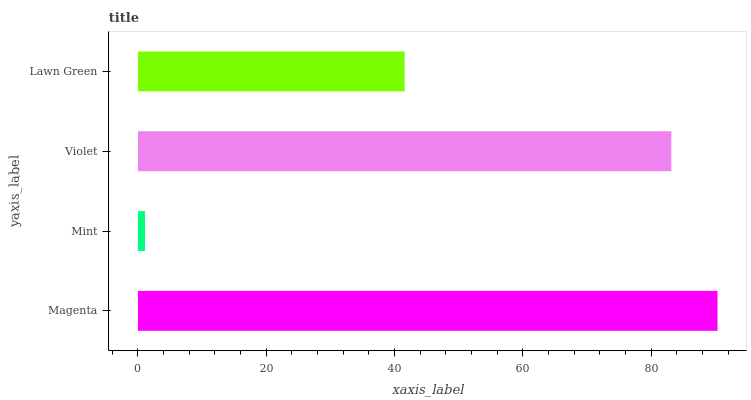Is Mint the minimum?
Answer yes or no. Yes. Is Magenta the maximum?
Answer yes or no. Yes. Is Violet the minimum?
Answer yes or no. No. Is Violet the maximum?
Answer yes or no. No. Is Violet greater than Mint?
Answer yes or no. Yes. Is Mint less than Violet?
Answer yes or no. Yes. Is Mint greater than Violet?
Answer yes or no. No. Is Violet less than Mint?
Answer yes or no. No. Is Violet the high median?
Answer yes or no. Yes. Is Lawn Green the low median?
Answer yes or no. Yes. Is Mint the high median?
Answer yes or no. No. Is Violet the low median?
Answer yes or no. No. 